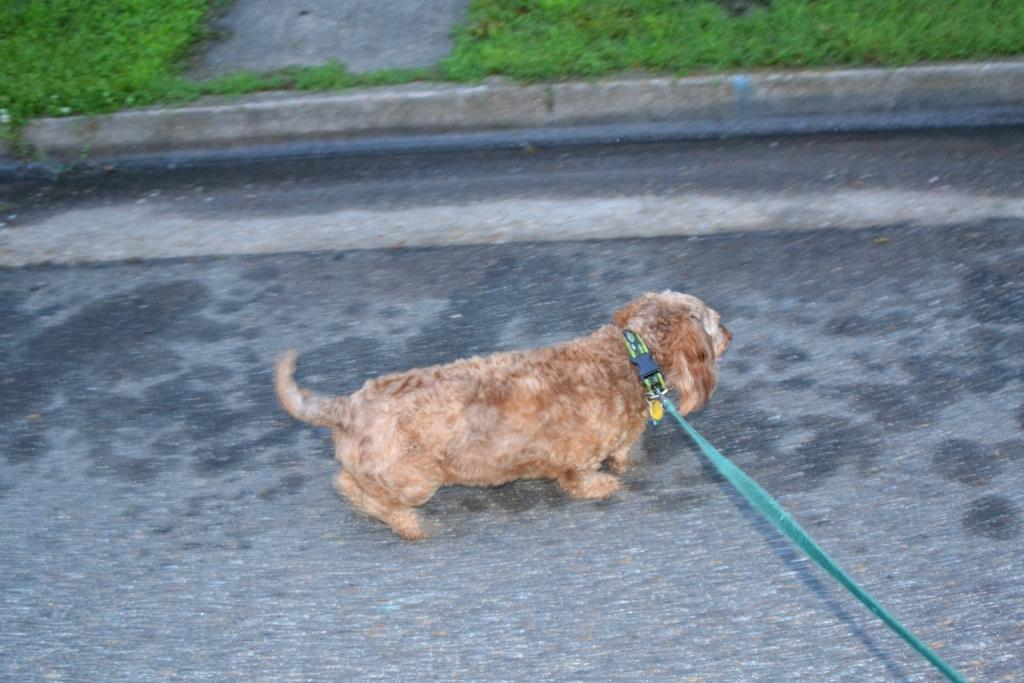What type of animal is present in the image? There is a dog in the image. What is the dog doing in the image? The dog is running on the floor. What type of surface is the dog running on? The dog is running on the floor. What can be seen in the background of the image? There is grass visible at the top of the image. What organization does the dog represent in the image? The image does not depict the dog as a representative of any organization. 